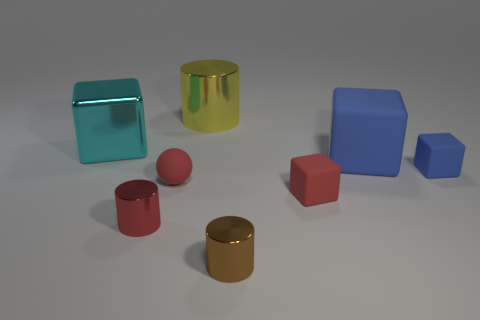Add 2 tiny balls. How many objects exist? 10 Subtract all cylinders. How many objects are left? 5 Add 4 brown objects. How many brown objects exist? 5 Subtract 0 cyan cylinders. How many objects are left? 8 Subtract all tiny brown cylinders. Subtract all small metal objects. How many objects are left? 5 Add 5 blue rubber things. How many blue rubber things are left? 7 